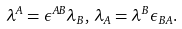Convert formula to latex. <formula><loc_0><loc_0><loc_500><loc_500>\lambda ^ { A } = \epsilon ^ { A B } \lambda _ { B } , \, \lambda _ { A } = \lambda ^ { B } \epsilon _ { B A } .</formula> 